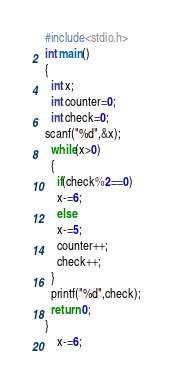Convert code to text. <code><loc_0><loc_0><loc_500><loc_500><_C_>#include<stdio.h>
int main()
{
  int x;
  int counter=0;
  int check=0;
scanf("%d",&x);
  while(x>0)
  {
    if(check%2==0)
    x-=6;
    else
    x-=5;
    counter++;
    check++;
  }
  printf("%d",check);
  return 0;
}
    x-=6;</code> 